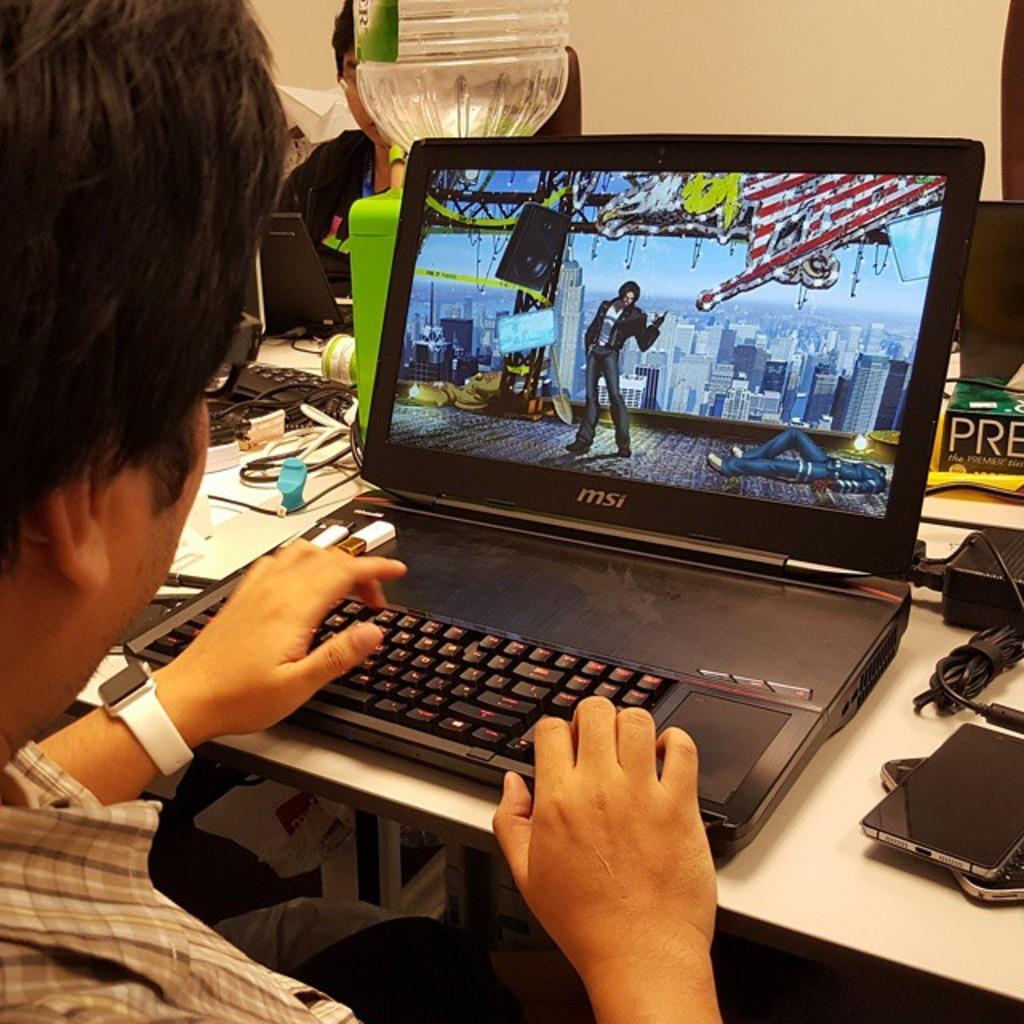What brand is the laptop?
Provide a succinct answer. Msi. 